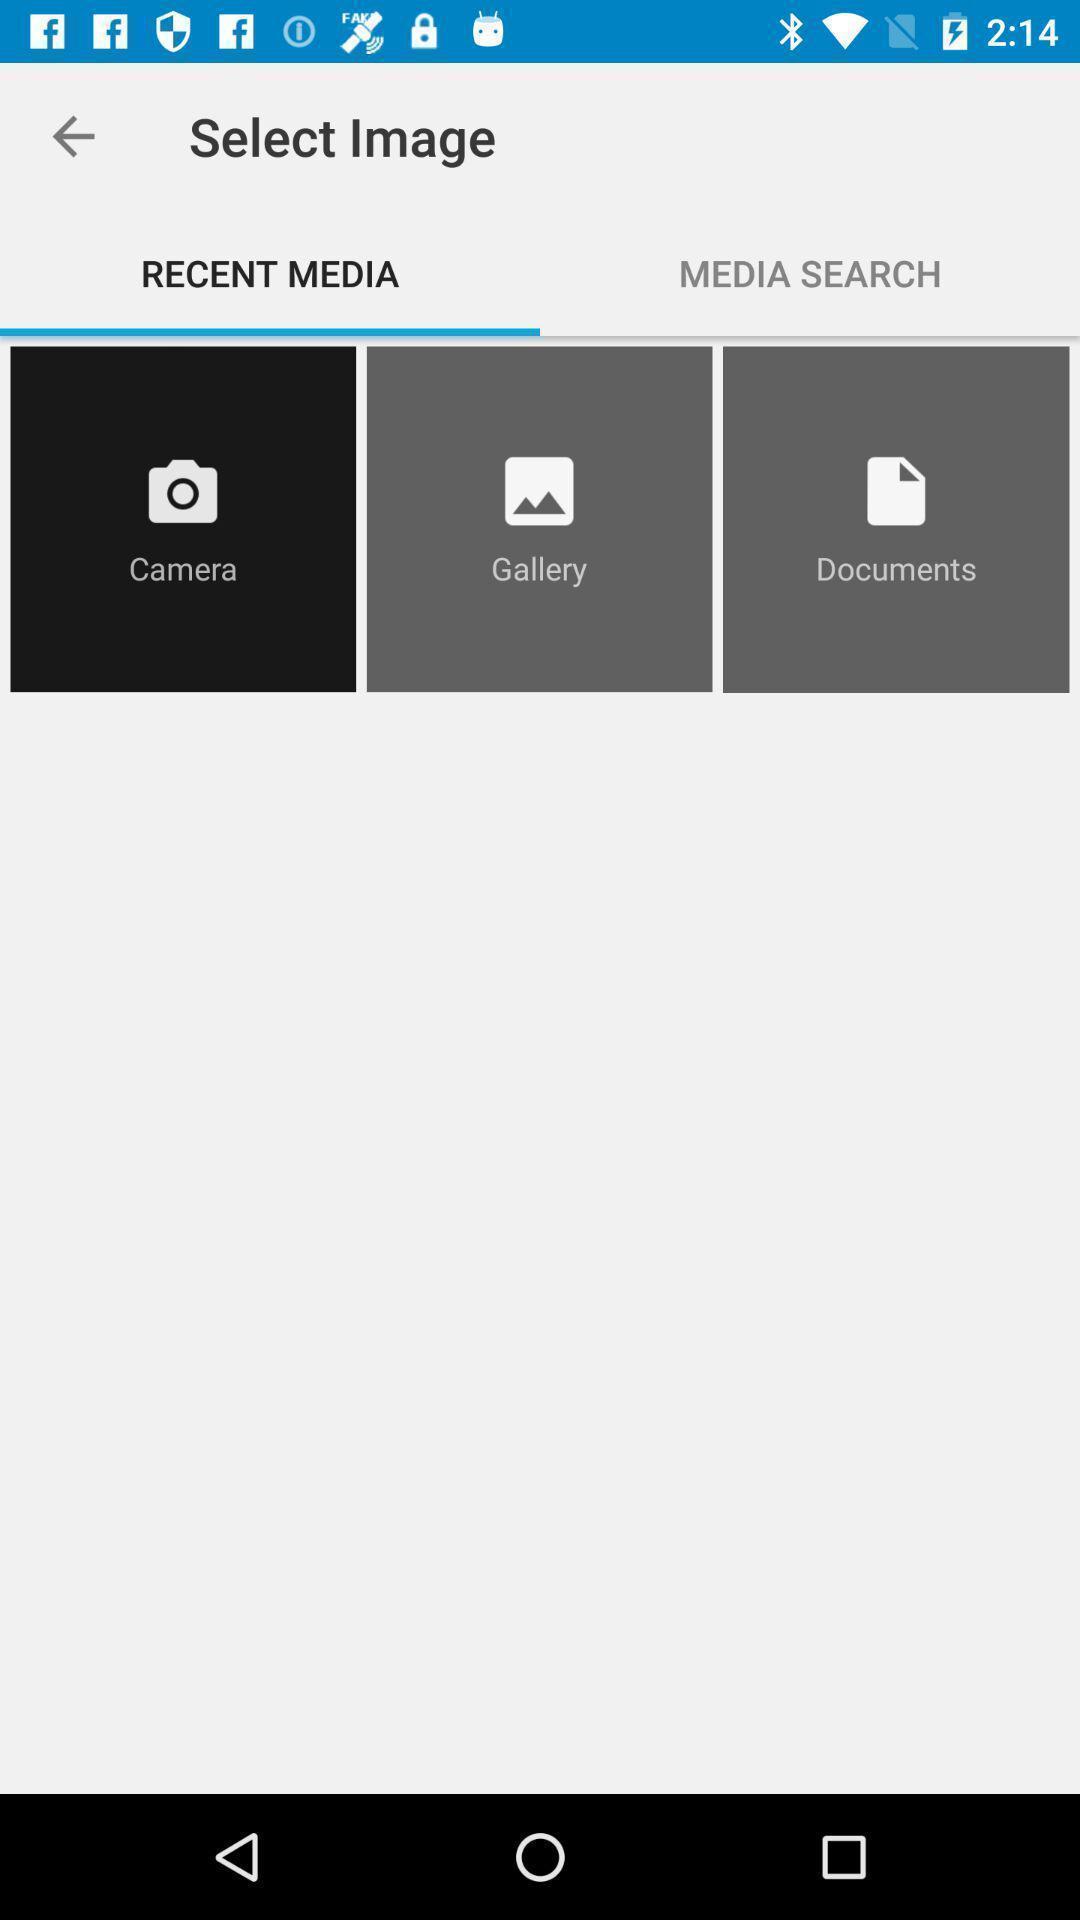Give me a narrative description of this picture. Screen shows to select images. 